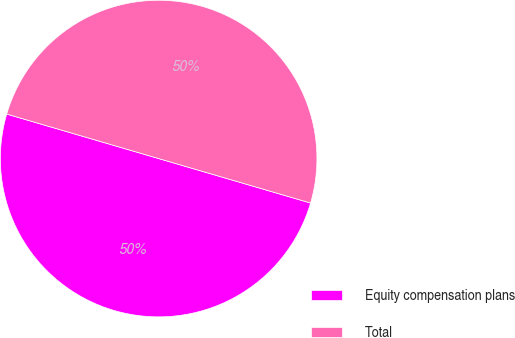Convert chart. <chart><loc_0><loc_0><loc_500><loc_500><pie_chart><fcel>Equity compensation plans<fcel>Total<nl><fcel>50.0%<fcel>50.0%<nl></chart> 